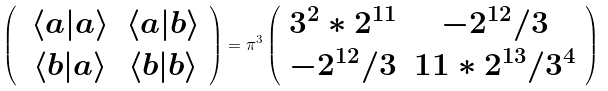Convert formula to latex. <formula><loc_0><loc_0><loc_500><loc_500>\left ( \begin{array} { c c } \, \langle a | a \rangle & \langle a | b \rangle \\ \, \langle b | a \rangle & \langle b | b \rangle \end{array} \right ) = \pi ^ { 3 } \left ( \begin{array} { c c } 3 ^ { 2 } * 2 ^ { 1 1 } & - 2 ^ { 1 2 } / 3 \\ - 2 ^ { 1 2 } / 3 & 1 1 * 2 ^ { 1 3 } / 3 ^ { 4 } \end{array} \right )</formula> 